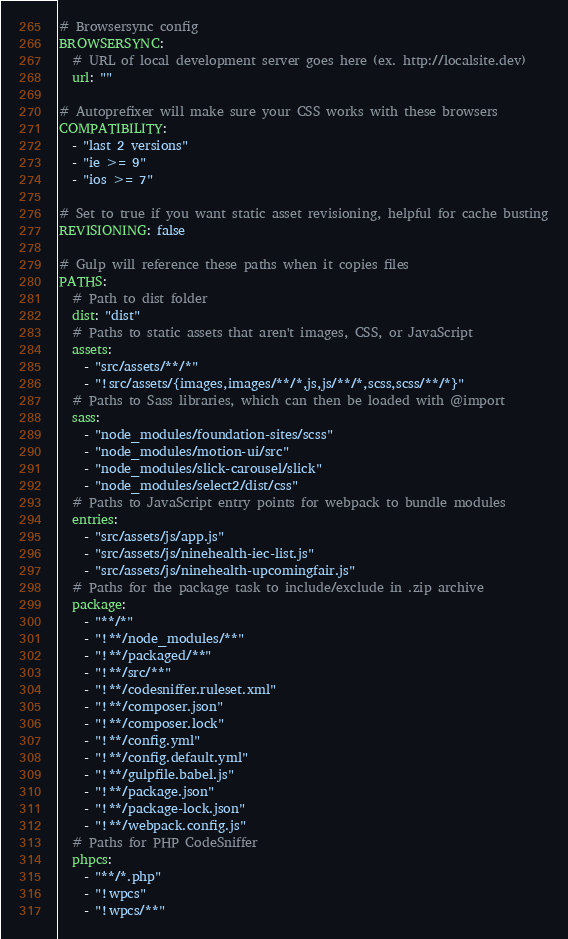Convert code to text. <code><loc_0><loc_0><loc_500><loc_500><_YAML_># Browsersync config
BROWSERSYNC:
  # URL of local development server goes here (ex. http://localsite.dev)
  url: ""

# Autoprefixer will make sure your CSS works with these browsers
COMPATIBILITY:
  - "last 2 versions"
  - "ie >= 9"
  - "ios >= 7"

# Set to true if you want static asset revisioning, helpful for cache busting
REVISIONING: false

# Gulp will reference these paths when it copies files
PATHS:
  # Path to dist folder
  dist: "dist"
  # Paths to static assets that aren't images, CSS, or JavaScript
  assets:
    - "src/assets/**/*"
    - "!src/assets/{images,images/**/*,js,js/**/*,scss,scss/**/*}"
  # Paths to Sass libraries, which can then be loaded with @import
  sass:
    - "node_modules/foundation-sites/scss"
    - "node_modules/motion-ui/src"
    - "node_modules/slick-carousel/slick"
    - "node_modules/select2/dist/css"
  # Paths to JavaScript entry points for webpack to bundle modules
  entries:
    - "src/assets/js/app.js"
    - "src/assets/js/ninehealth-iec-list.js"
    - "src/assets/js/ninehealth-upcomingfair.js"
  # Paths for the package task to include/exclude in .zip archive
  package:
    - "**/*"
    - "!**/node_modules/**"
    - "!**/packaged/**"
    - "!**/src/**"
    - "!**/codesniffer.ruleset.xml"
    - "!**/composer.json"
    - "!**/composer.lock"
    - "!**/config.yml"
    - "!**/config.default.yml"
    - "!**/gulpfile.babel.js"
    - "!**/package.json"
    - "!**/package-lock.json"
    - "!**/webpack.config.js"
  # Paths for PHP CodeSniffer
  phpcs:
    - "**/*.php"
    - "!wpcs"
    - "!wpcs/**"
</code> 